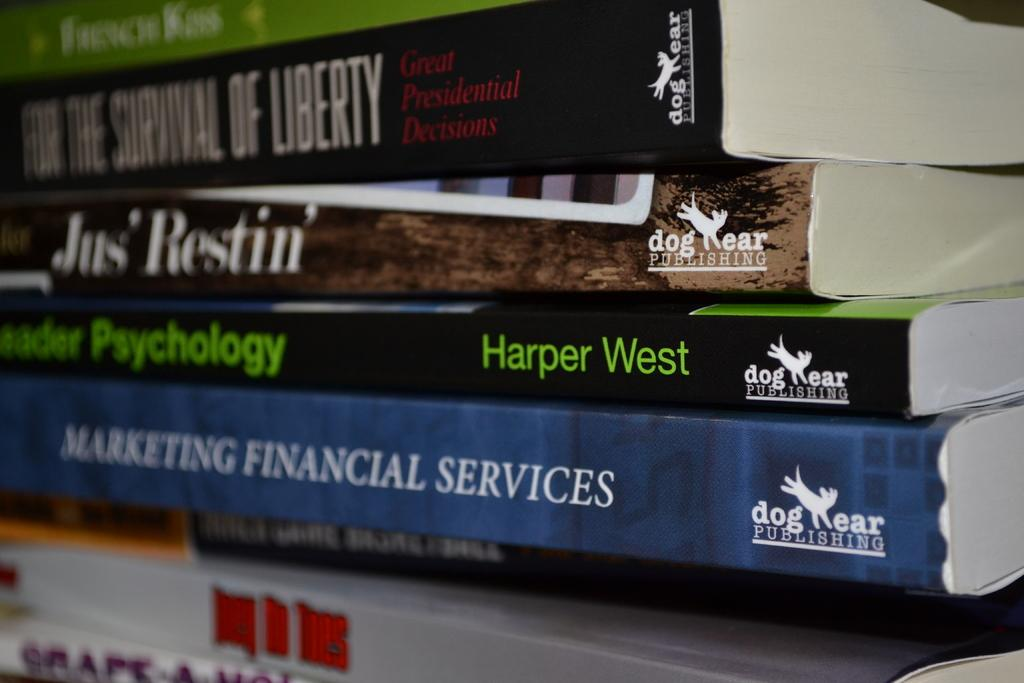<image>
Share a concise interpretation of the image provided. a marketing financial services book at the bottom of a pile 